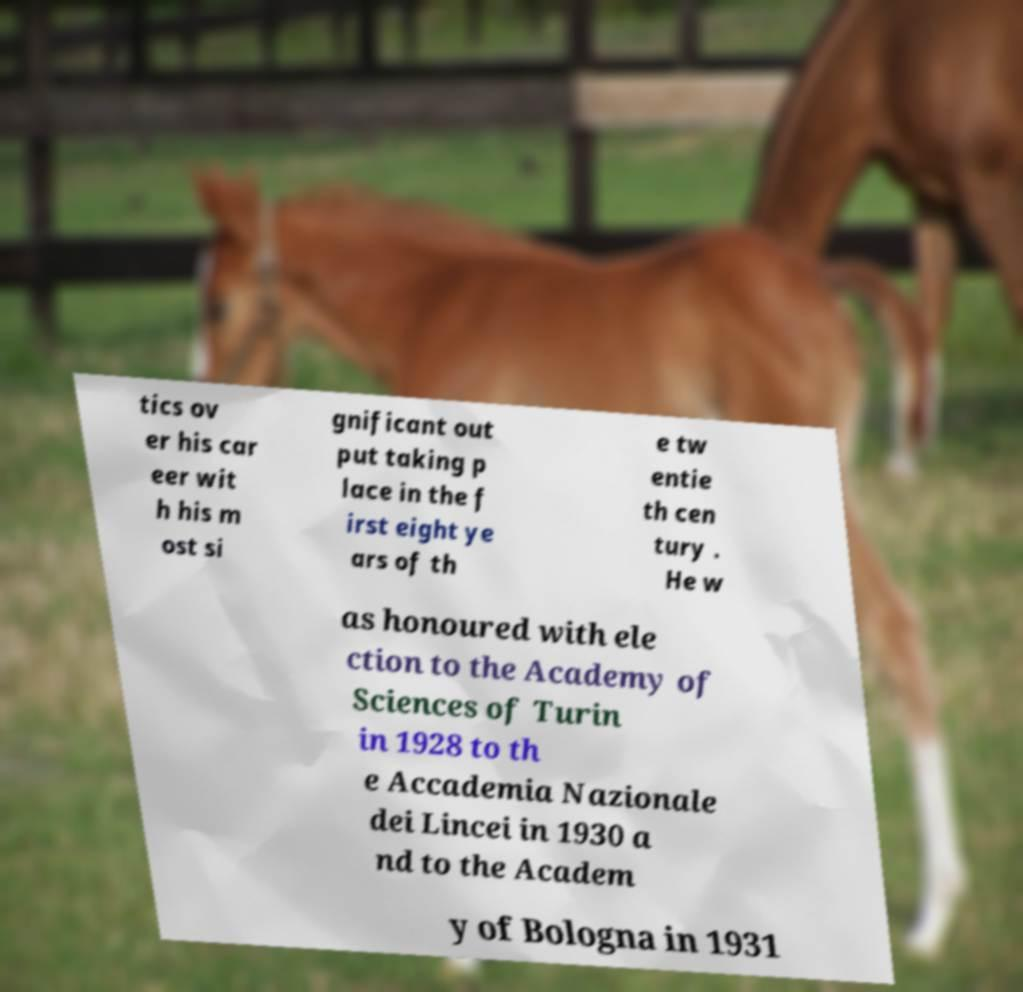Please identify and transcribe the text found in this image. tics ov er his car eer wit h his m ost si gnificant out put taking p lace in the f irst eight ye ars of th e tw entie th cen tury . He w as honoured with ele ction to the Academy of Sciences of Turin in 1928 to th e Accademia Nazionale dei Lincei in 1930 a nd to the Academ y of Bologna in 1931 